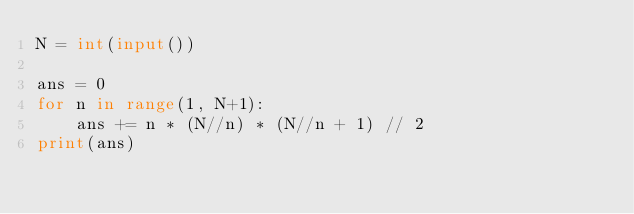<code> <loc_0><loc_0><loc_500><loc_500><_Python_>N = int(input())

ans = 0
for n in range(1, N+1):
    ans += n * (N//n) * (N//n + 1) // 2
print(ans)</code> 